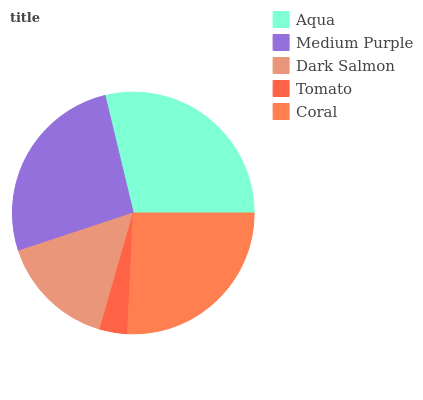Is Tomato the minimum?
Answer yes or no. Yes. Is Aqua the maximum?
Answer yes or no. Yes. Is Medium Purple the minimum?
Answer yes or no. No. Is Medium Purple the maximum?
Answer yes or no. No. Is Aqua greater than Medium Purple?
Answer yes or no. Yes. Is Medium Purple less than Aqua?
Answer yes or no. Yes. Is Medium Purple greater than Aqua?
Answer yes or no. No. Is Aqua less than Medium Purple?
Answer yes or no. No. Is Coral the high median?
Answer yes or no. Yes. Is Coral the low median?
Answer yes or no. Yes. Is Aqua the high median?
Answer yes or no. No. Is Medium Purple the low median?
Answer yes or no. No. 